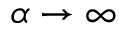Convert formula to latex. <formula><loc_0><loc_0><loc_500><loc_500>\alpha \to \infty</formula> 